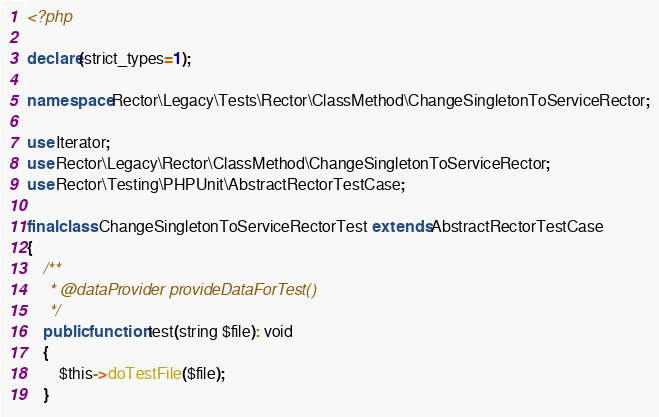<code> <loc_0><loc_0><loc_500><loc_500><_PHP_><?php

declare(strict_types=1);

namespace Rector\Legacy\Tests\Rector\ClassMethod\ChangeSingletonToServiceRector;

use Iterator;
use Rector\Legacy\Rector\ClassMethod\ChangeSingletonToServiceRector;
use Rector\Testing\PHPUnit\AbstractRectorTestCase;

final class ChangeSingletonToServiceRectorTest extends AbstractRectorTestCase
{
    /**
     * @dataProvider provideDataForTest()
     */
    public function test(string $file): void
    {
        $this->doTestFile($file);
    }
</code> 